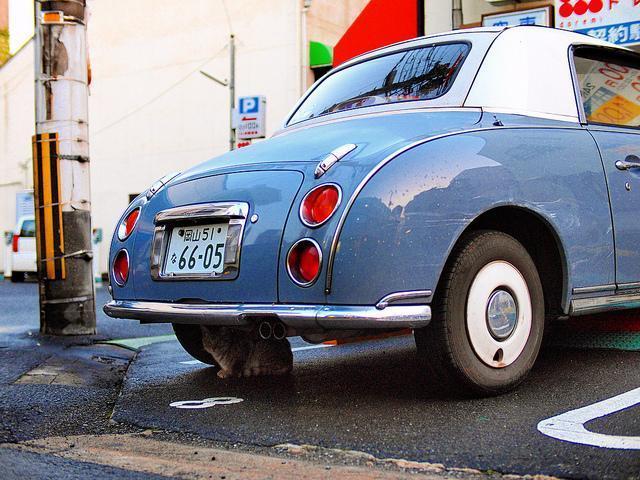How many orange papers are on the toilet?
Give a very brief answer. 0. 